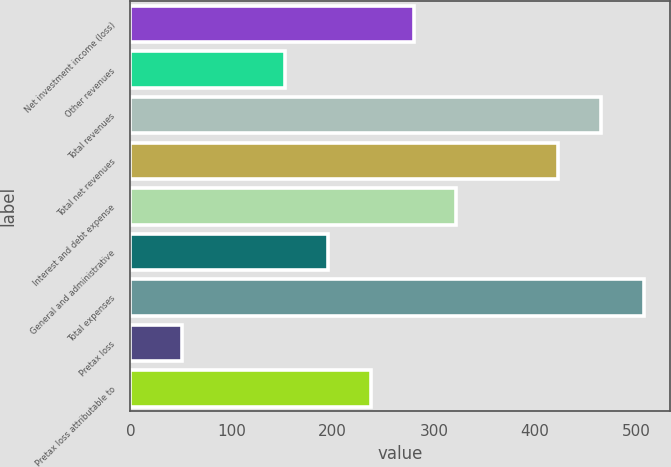<chart> <loc_0><loc_0><loc_500><loc_500><bar_chart><fcel>Net investment income (loss)<fcel>Other revenues<fcel>Total revenues<fcel>Total net revenues<fcel>Interest and debt expense<fcel>General and administrative<fcel>Total expenses<fcel>Pretax loss<fcel>Pretax loss attributable to<nl><fcel>279.9<fcel>153<fcel>465.3<fcel>423<fcel>322.2<fcel>195.3<fcel>507.6<fcel>51<fcel>237.6<nl></chart> 